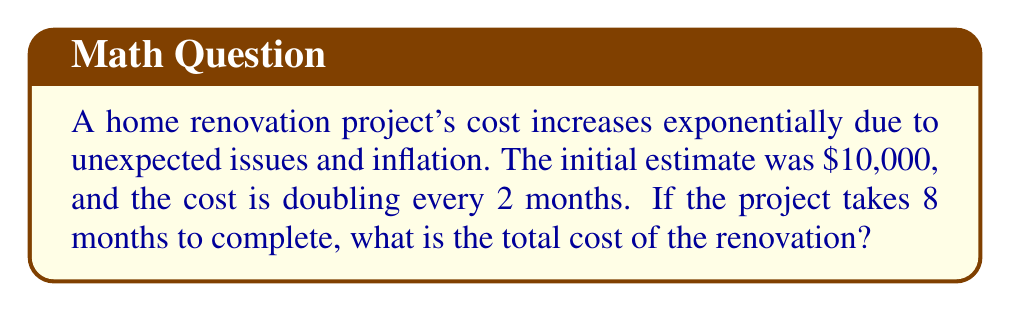Solve this math problem. Let's approach this step-by-step:

1) We can model this situation using the exponential function:
   $C(t) = 10000 \cdot 2^{t/2}$
   where $C(t)$ is the cost after $t$ months.

2) We need to find $C(8)$ since the project takes 8 months.

3) Plugging in $t=8$ into our function:
   $C(8) = 10000 \cdot 2^{8/2}$

4) Simplify the exponent:
   $C(8) = 10000 \cdot 2^4$

5) Calculate $2^4$:
   $C(8) = 10000 \cdot 16$

6) Multiply:
   $C(8) = 160000$

Therefore, after 8 months, the cost of the renovation project will be $160,000.
Answer: $160,000 